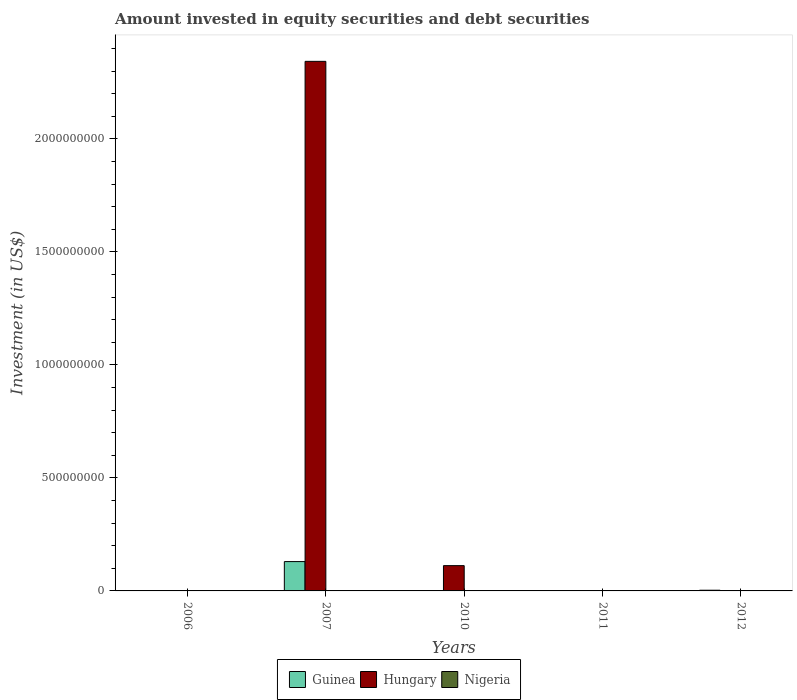How many different coloured bars are there?
Give a very brief answer. 2. Are the number of bars per tick equal to the number of legend labels?
Keep it short and to the point. No. How many bars are there on the 1st tick from the right?
Keep it short and to the point. 1. What is the label of the 5th group of bars from the left?
Your response must be concise. 2012. What is the amount invested in equity securities and debt securities in Nigeria in 2007?
Provide a succinct answer. 0. Across all years, what is the maximum amount invested in equity securities and debt securities in Guinea?
Keep it short and to the point. 1.30e+08. Across all years, what is the minimum amount invested in equity securities and debt securities in Nigeria?
Your answer should be compact. 0. What is the total amount invested in equity securities and debt securities in Nigeria in the graph?
Your answer should be compact. 0. What is the difference between the amount invested in equity securities and debt securities in Guinea in 2007 and that in 2012?
Your answer should be very brief. 1.27e+08. What is the average amount invested in equity securities and debt securities in Guinea per year?
Keep it short and to the point. 2.66e+07. What is the ratio of the amount invested in equity securities and debt securities in Hungary in 2007 to that in 2010?
Give a very brief answer. 20.95. Is the amount invested in equity securities and debt securities in Guinea in 2007 less than that in 2012?
Ensure brevity in your answer.  No. What is the difference between the highest and the lowest amount invested in equity securities and debt securities in Guinea?
Ensure brevity in your answer.  1.30e+08. In how many years, is the amount invested in equity securities and debt securities in Guinea greater than the average amount invested in equity securities and debt securities in Guinea taken over all years?
Keep it short and to the point. 1. Is it the case that in every year, the sum of the amount invested in equity securities and debt securities in Hungary and amount invested in equity securities and debt securities in Guinea is greater than the amount invested in equity securities and debt securities in Nigeria?
Keep it short and to the point. No. How many bars are there?
Your answer should be compact. 4. How many legend labels are there?
Ensure brevity in your answer.  3. How are the legend labels stacked?
Give a very brief answer. Horizontal. What is the title of the graph?
Keep it short and to the point. Amount invested in equity securities and debt securities. Does "Sint Maarten (Dutch part)" appear as one of the legend labels in the graph?
Give a very brief answer. No. What is the label or title of the Y-axis?
Offer a very short reply. Investment (in US$). What is the Investment (in US$) of Guinea in 2006?
Provide a succinct answer. 0. What is the Investment (in US$) in Hungary in 2006?
Make the answer very short. 0. What is the Investment (in US$) of Guinea in 2007?
Your response must be concise. 1.30e+08. What is the Investment (in US$) in Hungary in 2007?
Give a very brief answer. 2.34e+09. What is the Investment (in US$) of Nigeria in 2007?
Provide a succinct answer. 0. What is the Investment (in US$) of Hungary in 2010?
Your answer should be compact. 1.12e+08. What is the Investment (in US$) of Guinea in 2011?
Provide a succinct answer. 0. What is the Investment (in US$) of Hungary in 2011?
Offer a terse response. 0. What is the Investment (in US$) of Nigeria in 2011?
Your answer should be very brief. 0. What is the Investment (in US$) in Guinea in 2012?
Your response must be concise. 3.08e+06. Across all years, what is the maximum Investment (in US$) of Guinea?
Offer a terse response. 1.30e+08. Across all years, what is the maximum Investment (in US$) in Hungary?
Ensure brevity in your answer.  2.34e+09. Across all years, what is the minimum Investment (in US$) in Guinea?
Keep it short and to the point. 0. Across all years, what is the minimum Investment (in US$) in Hungary?
Offer a very short reply. 0. What is the total Investment (in US$) of Guinea in the graph?
Offer a terse response. 1.33e+08. What is the total Investment (in US$) of Hungary in the graph?
Offer a terse response. 2.45e+09. What is the total Investment (in US$) in Nigeria in the graph?
Give a very brief answer. 0. What is the difference between the Investment (in US$) of Hungary in 2007 and that in 2010?
Provide a short and direct response. 2.23e+09. What is the difference between the Investment (in US$) in Guinea in 2007 and that in 2012?
Provide a succinct answer. 1.27e+08. What is the difference between the Investment (in US$) in Guinea in 2007 and the Investment (in US$) in Hungary in 2010?
Keep it short and to the point. 1.79e+07. What is the average Investment (in US$) of Guinea per year?
Make the answer very short. 2.66e+07. What is the average Investment (in US$) in Hungary per year?
Provide a succinct answer. 4.91e+08. What is the average Investment (in US$) of Nigeria per year?
Your answer should be very brief. 0. In the year 2007, what is the difference between the Investment (in US$) in Guinea and Investment (in US$) in Hungary?
Provide a short and direct response. -2.21e+09. What is the ratio of the Investment (in US$) in Hungary in 2007 to that in 2010?
Offer a very short reply. 20.95. What is the ratio of the Investment (in US$) in Guinea in 2007 to that in 2012?
Provide a succinct answer. 42.13. What is the difference between the highest and the lowest Investment (in US$) in Guinea?
Keep it short and to the point. 1.30e+08. What is the difference between the highest and the lowest Investment (in US$) of Hungary?
Offer a terse response. 2.34e+09. 